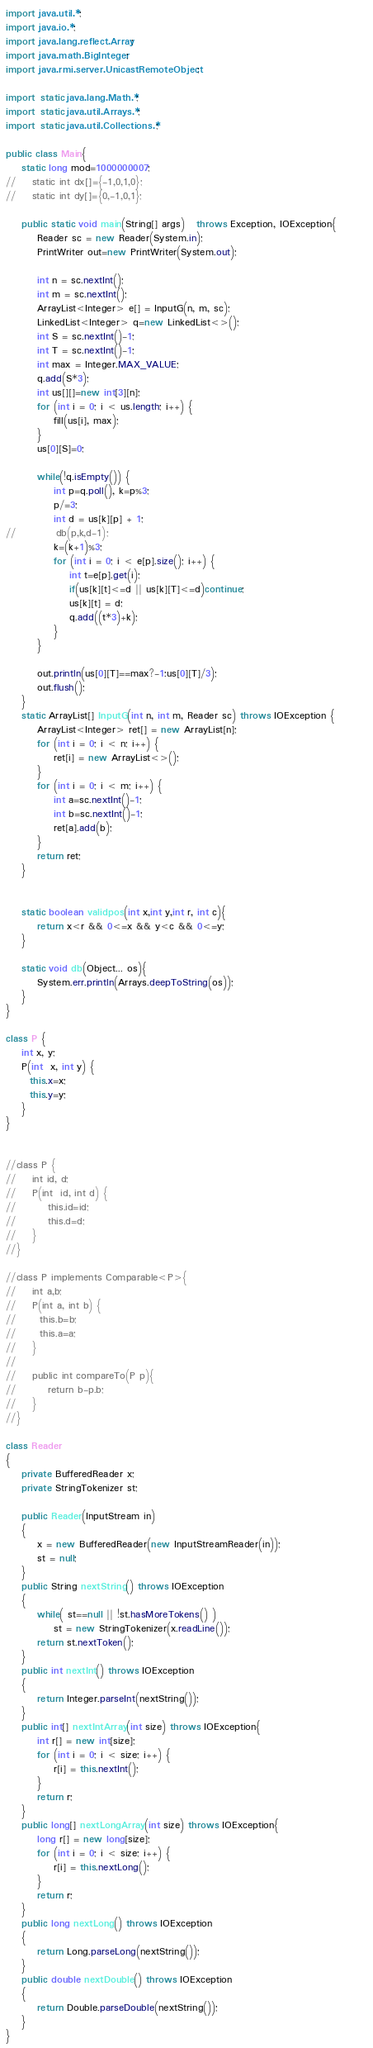Convert code to text. <code><loc_0><loc_0><loc_500><loc_500><_Java_>import java.util.*;
import java.io.*;
import java.lang.reflect.Array;
import java.math.BigInteger;
import java.rmi.server.UnicastRemoteObject;

import static java.lang.Math.*;
import static java.util.Arrays.*;
import static java.util.Collections.*;
 
public class Main{
    static long mod=1000000007;
//    static int dx[]={-1,0,1,0};
//    static int dy[]={0,-1,0,1};

    public static void main(String[] args)   throws Exception, IOException{        
        Reader sc = new Reader(System.in);
        PrintWriter out=new PrintWriter(System.out);

        int n = sc.nextInt();
        int m = sc.nextInt();
        ArrayList<Integer> e[] = InputG(n, m, sc);
        LinkedList<Integer> q=new LinkedList<>();
        int S = sc.nextInt()-1;
        int T = sc.nextInt()-1;
        int max = Integer.MAX_VALUE;
        q.add(S*3);
        int us[][]=new int[3][n];
        for (int i = 0; i < us.length; i++) {
			fill(us[i], max);
		}
        us[0][S]=0;

        while(!q.isEmpty()) {
        	int p=q.poll(), k=p%3;
        	p/=3;
        	int d = us[k][p] + 1;
//        	db(p,k,d-1);
        	k=(k+1)%3;
        	for (int i = 0; i < e[p].size(); i++) {
				int t=e[p].get(i);
				if(us[k][t]<=d || us[k][T]<=d)continue;
		        us[k][t] = d;
				q.add((t*3)+k);
			}
        }
        
        out.println(us[0][T]==max?-1:us[0][T]/3);
        out.flush();
    }
    static ArrayList[] InputG(int n, int m, Reader sc) throws IOException {
        ArrayList<Integer> ret[] = new ArrayList[n];
        for (int i = 0; i < n; i++) {
            ret[i] = new ArrayList<>();
        }
        for (int i = 0; i < m; i++) {
            int a=sc.nextInt()-1;
            int b=sc.nextInt()-1;
            ret[a].add(b);
        }
        return ret;
    }


    static boolean validpos(int x,int y,int r, int c){
        return x<r && 0<=x && y<c && 0<=y;
    }

    static void db(Object... os){
        System.err.println(Arrays.deepToString(os));
    }
}

class P {
	int x, y;
	P(int  x, int y) {
	  this.x=x;
	  this.y=y;
	}
}


//class P {
//    int id, d;
//    P(int  id, int d) {
//        this.id=id;
//        this.d=d;
//    }
//}

//class P implements Comparable<P>{
//    int a,b;
//    P(int a, int b) {
//    	this.b=b;
//    	this.a=a;
//    }
//
//    public int compareTo(P p){
//        return b-p.b;
//    }
//}

class Reader
{ 
    private BufferedReader x;
    private StringTokenizer st;
    
    public Reader(InputStream in)
    {
        x = new BufferedReader(new InputStreamReader(in));
        st = null;
    }
    public String nextString() throws IOException
    {
        while( st==null || !st.hasMoreTokens() )
            st = new StringTokenizer(x.readLine());
        return st.nextToken();
    }
    public int nextInt() throws IOException
    {
        return Integer.parseInt(nextString());
    }
    public int[] nextIntArray(int size) throws IOException{
        int r[] = new int[size];
        for (int i = 0; i < size; i++) {
            r[i] = this.nextInt(); 
        }
        return r;
    }
    public long[] nextLongArray(int size) throws IOException{
        long r[] = new long[size];
        for (int i = 0; i < size; i++) {
            r[i] = this.nextLong(); 
        }
        return r;
    }
    public long nextLong() throws IOException
    {
        return Long.parseLong(nextString());
    }
    public double nextDouble() throws IOException
    {
        return Double.parseDouble(nextString());
    }
}
</code> 